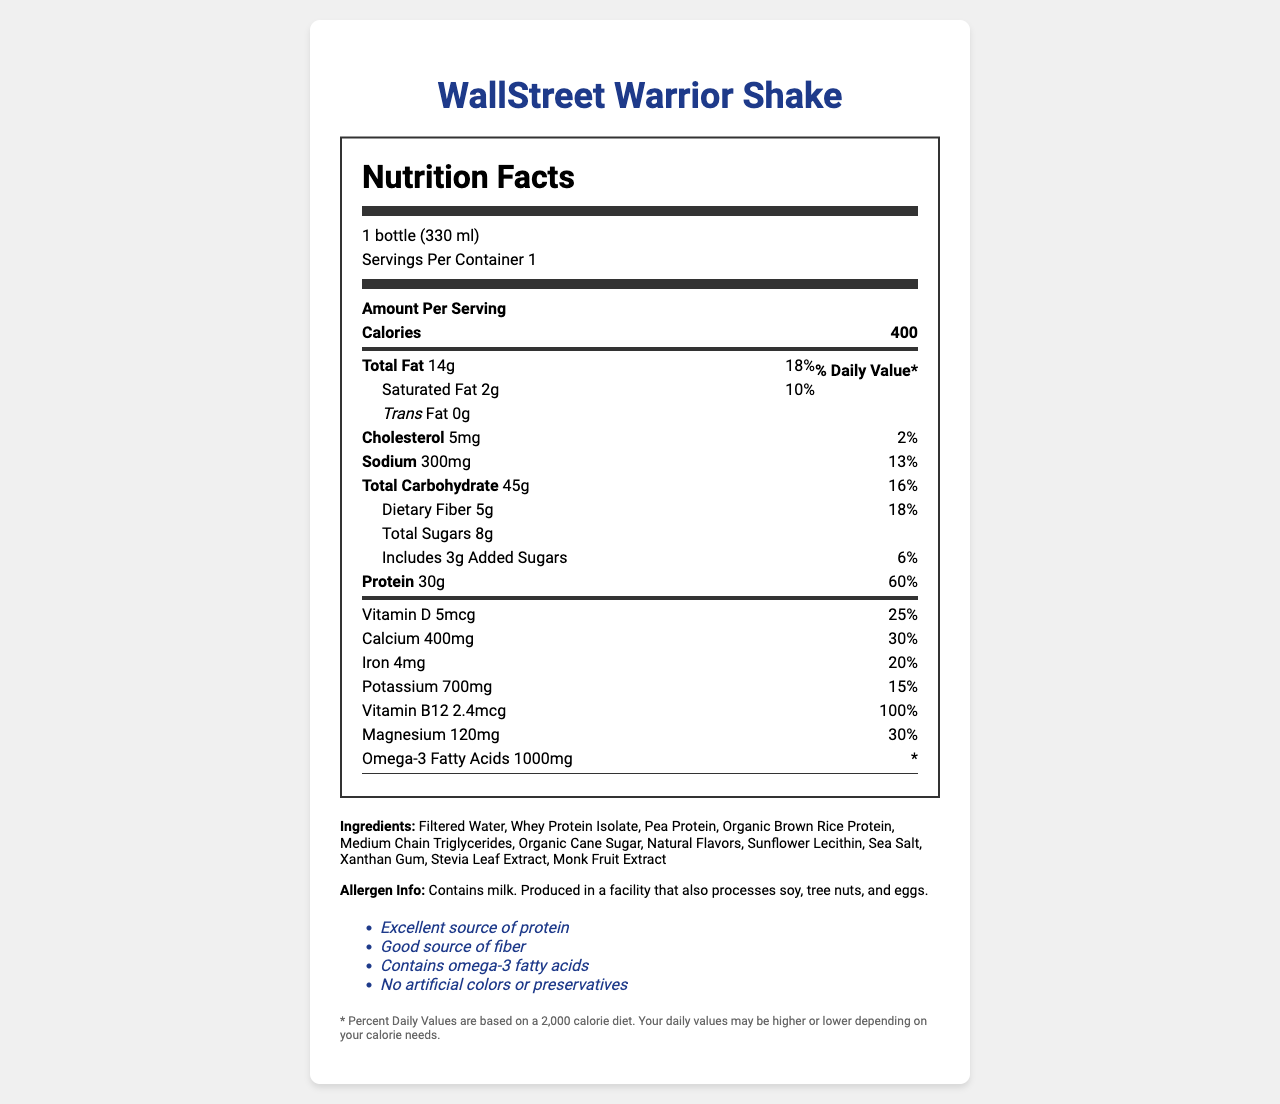what is the serving size? The serving size is explicitly listed as "1 bottle (330 ml)" in the document.
Answer: 1 bottle (330 ml) how many grams of total fat are in one serving? The document lists the total fat in one serving as "14g".
Answer: 14g what percentage of daily value for protein is provided by this product? This information is found in the protein section, where the daily value percentage is stated as "60%".
Answer: 60% what are the ingredients in the WallStreet Warrior Shake? The ingredients are listed under the "Ingredients" section in the document.
Answer: Filtered Water, Whey Protein Isolate, Pea Protein, Organic Brown Rice Protein, Medium Chain Triglycerides, Organic Cane Sugar, Natural Flavors, Sunflower Lecithin, Sea Salt, Xanthan Gum, Stevia Leaf Extract, Monk Fruit Extract how many milligrams of calcium does one serving of this shake contain? The document lists the amount of calcium as "400mg".
Answer: 400mg is there any cholesterol in the WallStreet Warrior Shake? The document lists "5mg" of cholesterol in the nutrition facts.
Answer: Yes which of the following vitamins or minerals is included at 100% daily value in the shake?
A. Vitamin D
B. Iron
C. Vitamin B12
D. Magnesium The document states that Vitamin B12 has a daily value percentage of "100%".
Answer: C which allergen is explicitly mentioned as contained in the WallStreet Warrior Shake?
A. Soy
B. Tree Nuts
C. Milk
D. Eggs The allergen information indicates the shake "contains milk".
Answer: C does the document provide information on how much omega-3 fatty acids contribute to the daily value percentage? The document states the amount of omega-3 fatty acids but does not include a daily value percentage.
Answer: No what type of protein is included in the shake besides whey protein isolate? The document lists Pea Protein and Organic Brown Rice Protein in the ingredients.
Answer: Pea Protein, Organic Brown Rice Protein how many health claims does the WallStreet Warrior Shake have? The document mentions four health claims in the "Health Claims" section.
Answer: Four does this product contain any artificial colors or preservatives? One of the health claims states "No artificial colors or preservatives".
Answer: No what is the main idea of the WallStreet Warrior Shake document? The document offers a comprehensive overview of the product, highlighting its nutritional content, what it contains, potential allergens, and health benefits.
Answer: The document provides detailed information about the nutrition facts, ingredients, allergen information, and health claims of the WallStreet Warrior Shake, a meal replacement shake. can I find out the manufacturer's information of this product from the document? The document does not provide any information regarding the manufacturer or company behind the product.
Answer: No 